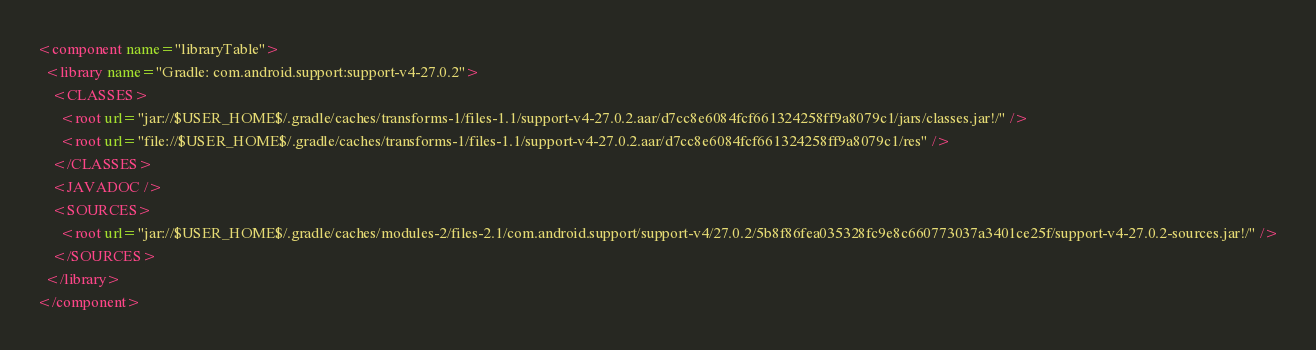<code> <loc_0><loc_0><loc_500><loc_500><_XML_><component name="libraryTable">
  <library name="Gradle: com.android.support:support-v4-27.0.2">
    <CLASSES>
      <root url="jar://$USER_HOME$/.gradle/caches/transforms-1/files-1.1/support-v4-27.0.2.aar/d7cc8e6084fcf661324258ff9a8079c1/jars/classes.jar!/" />
      <root url="file://$USER_HOME$/.gradle/caches/transforms-1/files-1.1/support-v4-27.0.2.aar/d7cc8e6084fcf661324258ff9a8079c1/res" />
    </CLASSES>
    <JAVADOC />
    <SOURCES>
      <root url="jar://$USER_HOME$/.gradle/caches/modules-2/files-2.1/com.android.support/support-v4/27.0.2/5b8f86fea035328fc9e8c660773037a3401ce25f/support-v4-27.0.2-sources.jar!/" />
    </SOURCES>
  </library>
</component></code> 